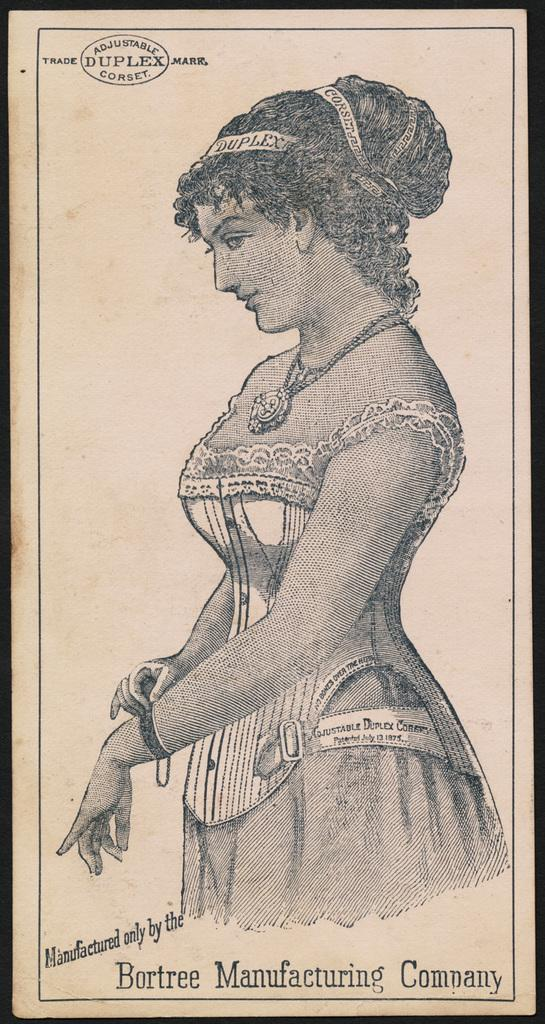What is depicted in the image? There is a sketch of a lady in the image. What is the medium of the sketch? The sketch is on a piece of paper. What additional information can be found at the top of the image? There is text at the top of the image. What other text is present in the image? There is text at the bottom of the image. What type of haircut does the lady have in the sketch? The image does not provide information about the lady's haircut in the sketch. What is the lady's mindset in the sketch? The image does not provide information about the lady's mindset in the sketch. 